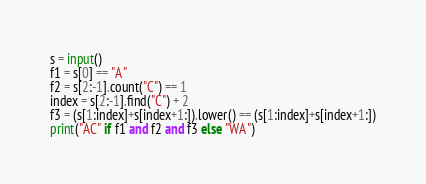<code> <loc_0><loc_0><loc_500><loc_500><_Python_>s = input()
f1 = s[0] == "A"
f2 = s[2:-1].count("C") == 1
index = s[2:-1].find("C") + 2
f3 = (s[1:index]+s[index+1:]).lower() == (s[1:index]+s[index+1:])
print("AC" if f1 and f2 and f3 else "WA")</code> 